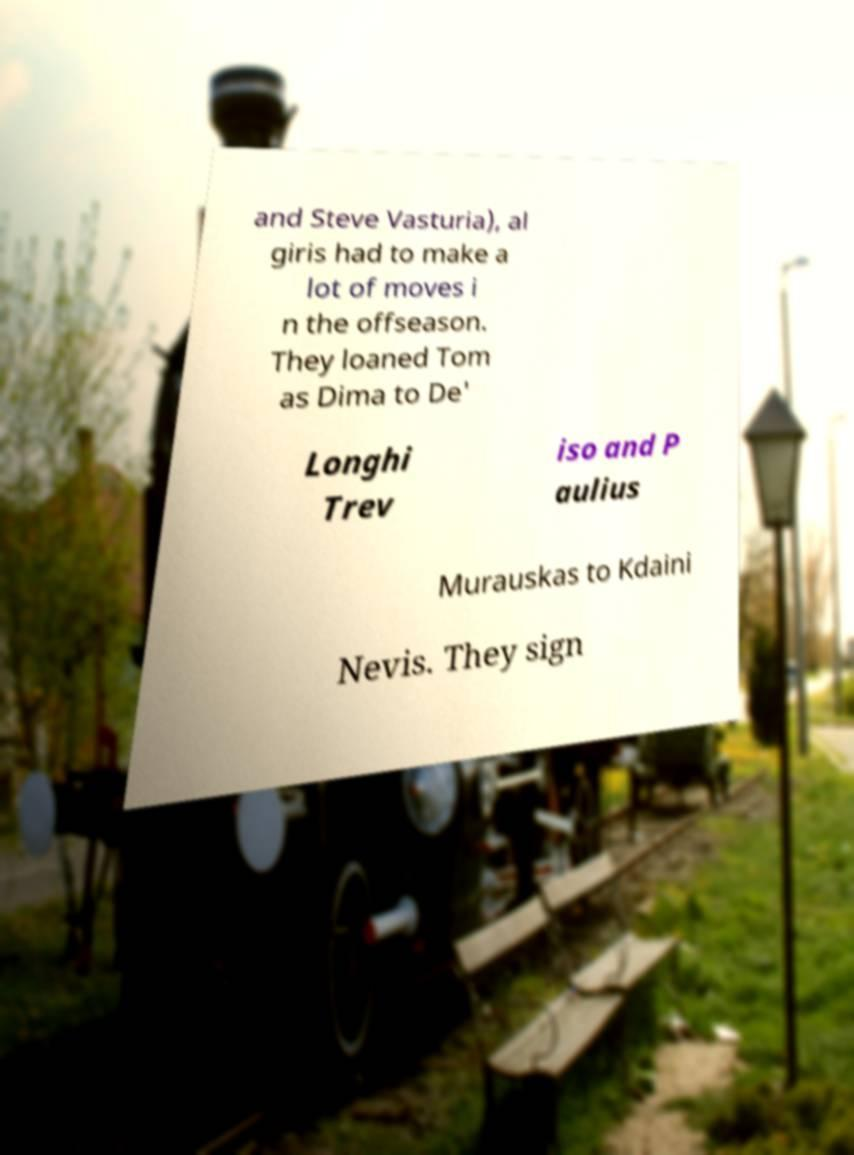Can you read and provide the text displayed in the image?This photo seems to have some interesting text. Can you extract and type it out for me? and Steve Vasturia), al giris had to make a lot of moves i n the offseason. They loaned Tom as Dima to De' Longhi Trev iso and P aulius Murauskas to Kdaini Nevis. They sign 